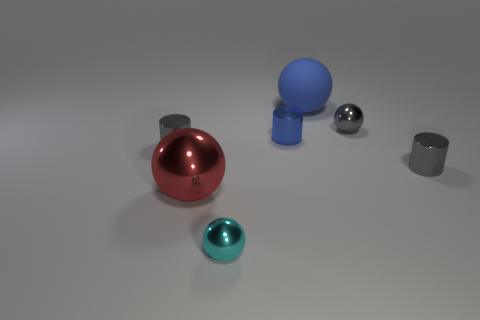Is there any other thing that is made of the same material as the large blue thing?
Offer a terse response. No. Does the blue sphere have the same material as the tiny ball on the left side of the blue metallic object?
Provide a short and direct response. No. Is the number of gray metal things that are on the left side of the small cyan metallic ball greater than the number of tiny purple rubber cylinders?
Make the answer very short. Yes. There is a thing that is the same color as the rubber ball; what is its shape?
Keep it short and to the point. Cylinder. Is there a blue ball made of the same material as the small cyan thing?
Your response must be concise. No. Do the big thing to the left of the rubber ball and the gray cylinder right of the small cyan metal object have the same material?
Ensure brevity in your answer.  Yes. Is the number of gray metal cylinders that are to the left of the blue metallic object the same as the number of gray metal cylinders that are to the left of the cyan shiny sphere?
Provide a succinct answer. Yes. What color is the object that is the same size as the red metallic ball?
Your answer should be compact. Blue. Is there another thing that has the same color as the large matte thing?
Offer a terse response. Yes. How many things are either small gray cylinders that are on the left side of the cyan ball or gray spheres?
Ensure brevity in your answer.  2. 